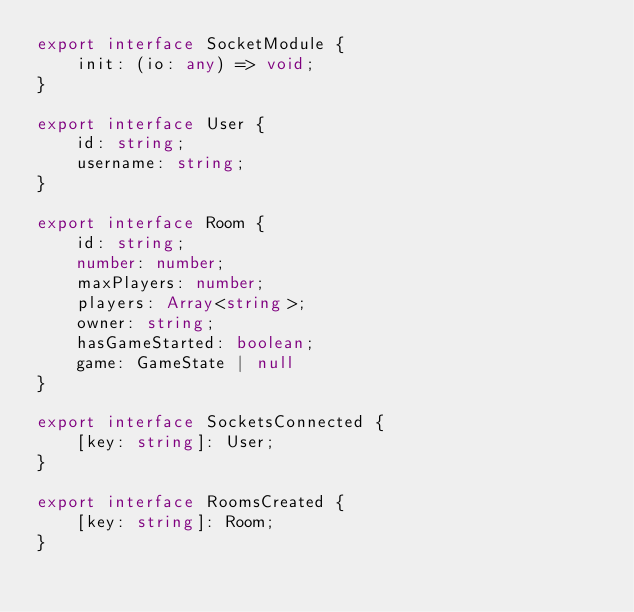<code> <loc_0><loc_0><loc_500><loc_500><_TypeScript_>export interface SocketModule {
    init: (io: any) => void;
}

export interface User {
    id: string;
    username: string;
}

export interface Room {
    id: string;
    number: number;
    maxPlayers: number;
    players: Array<string>;
    owner: string;
    hasGameStarted: boolean;
    game: GameState | null
}

export interface SocketsConnected {
    [key: string]: User;
}

export interface RoomsCreated {
    [key: string]: Room;
}</code> 